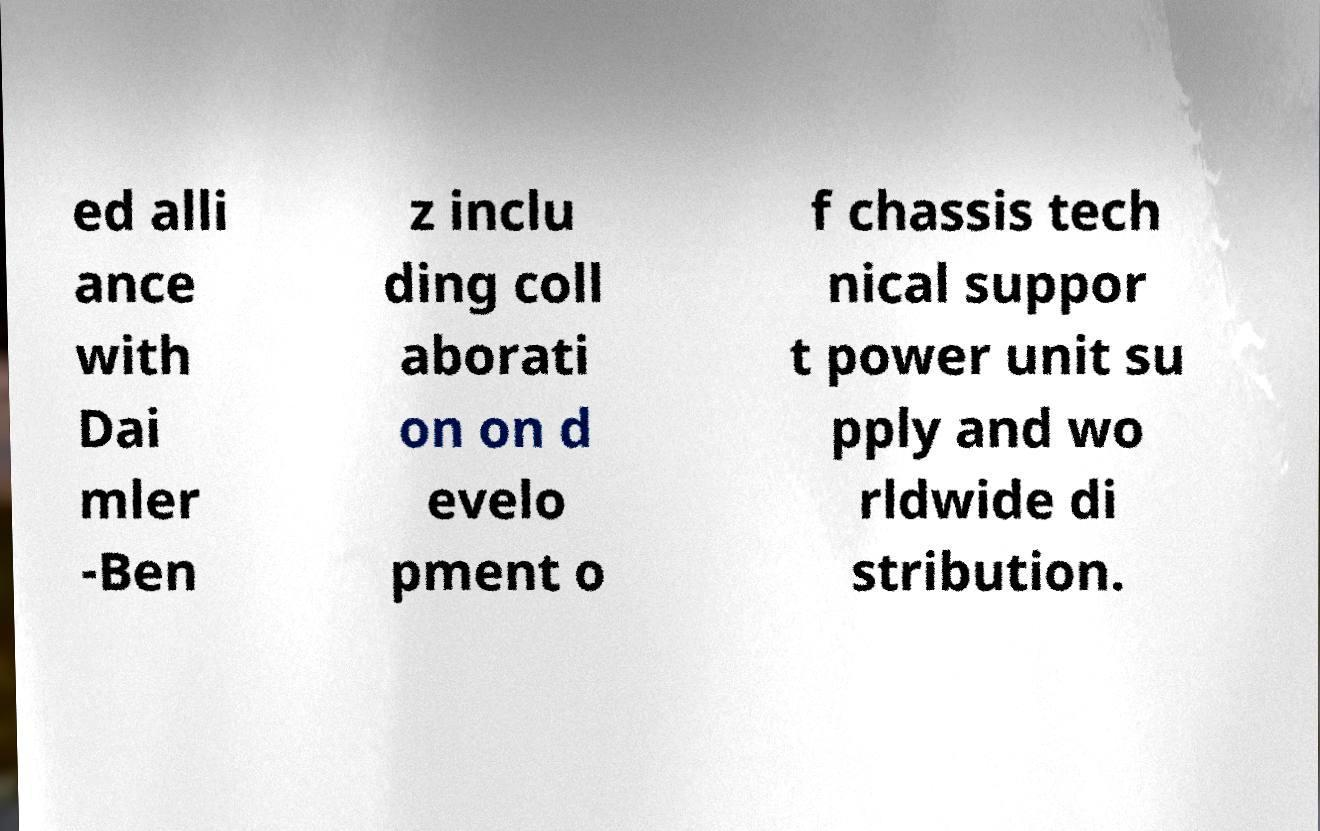For documentation purposes, I need the text within this image transcribed. Could you provide that? ed alli ance with Dai mler -Ben z inclu ding coll aborati on on d evelo pment o f chassis tech nical suppor t power unit su pply and wo rldwide di stribution. 